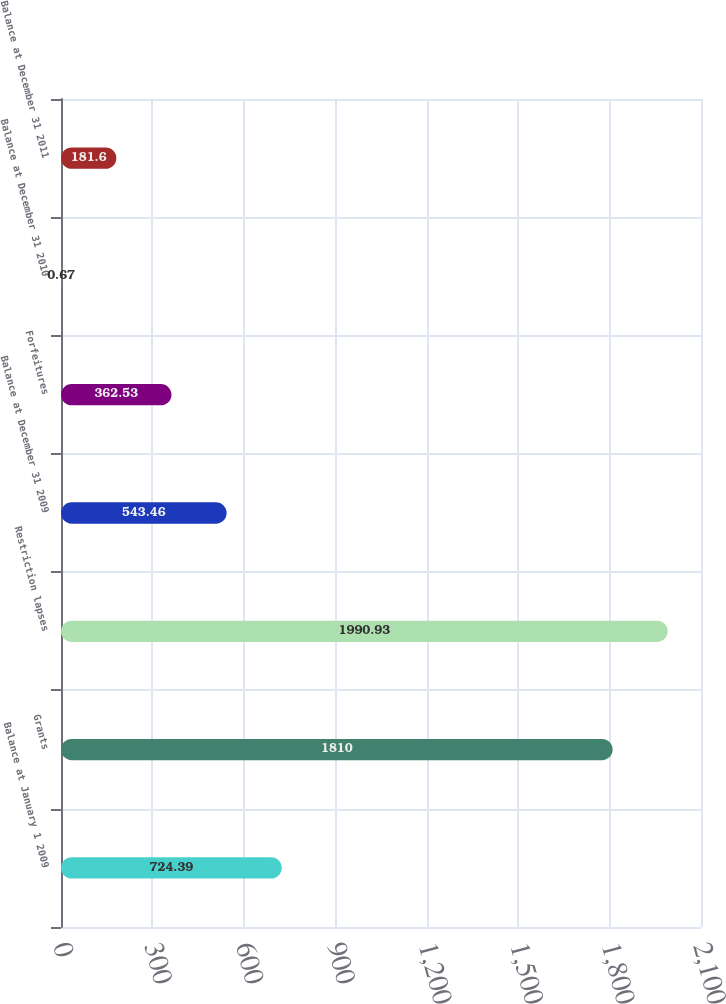Convert chart to OTSL. <chart><loc_0><loc_0><loc_500><loc_500><bar_chart><fcel>Balance at January 1 2009<fcel>Grants<fcel>Restriction lapses<fcel>Balance at December 31 2009<fcel>Forfeitures<fcel>Balance at December 31 2010<fcel>Balance at December 31 2011<nl><fcel>724.39<fcel>1810<fcel>1990.93<fcel>543.46<fcel>362.53<fcel>0.67<fcel>181.6<nl></chart> 